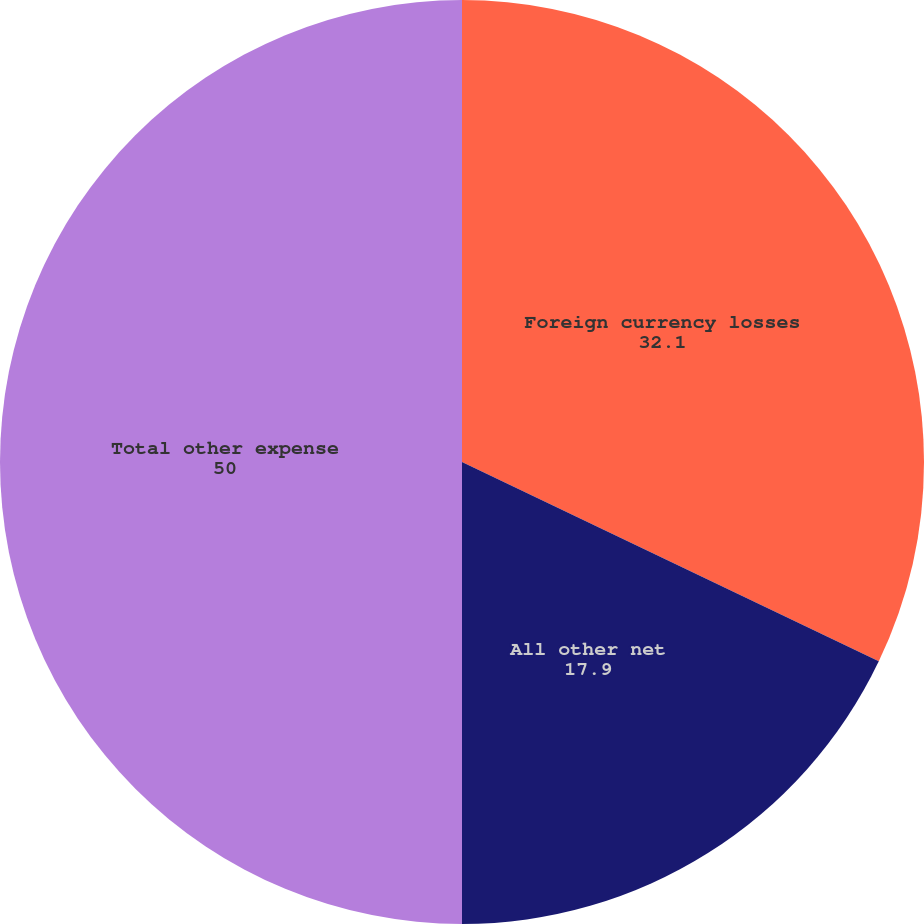Convert chart to OTSL. <chart><loc_0><loc_0><loc_500><loc_500><pie_chart><fcel>Foreign currency losses<fcel>All other net<fcel>Total other expense<nl><fcel>32.1%<fcel>17.9%<fcel>50.0%<nl></chart> 